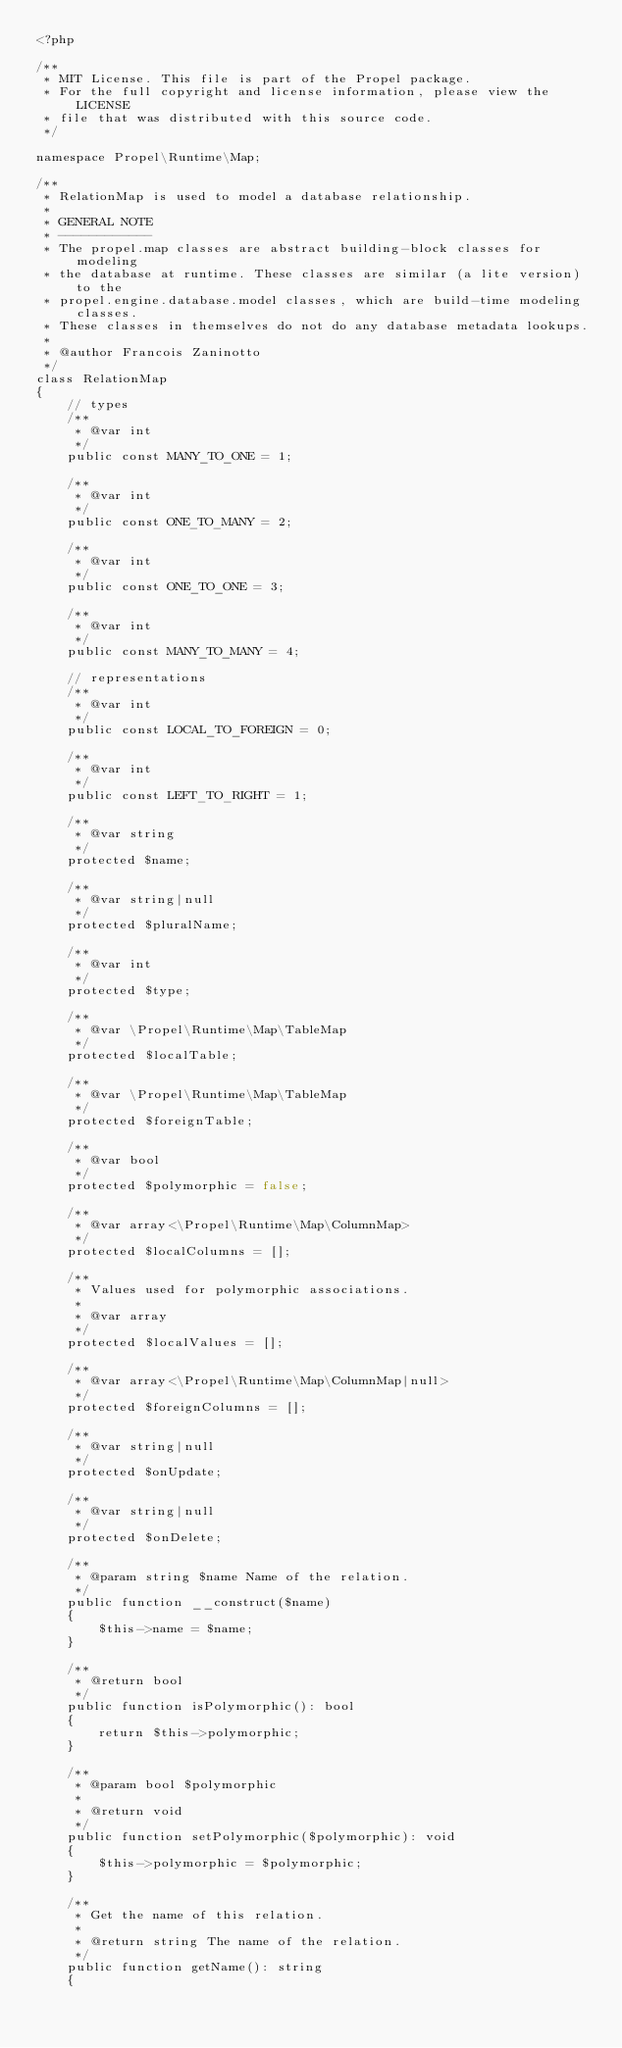Convert code to text. <code><loc_0><loc_0><loc_500><loc_500><_PHP_><?php

/**
 * MIT License. This file is part of the Propel package.
 * For the full copyright and license information, please view the LICENSE
 * file that was distributed with this source code.
 */

namespace Propel\Runtime\Map;

/**
 * RelationMap is used to model a database relationship.
 *
 * GENERAL NOTE
 * ------------
 * The propel.map classes are abstract building-block classes for modeling
 * the database at runtime. These classes are similar (a lite version) to the
 * propel.engine.database.model classes, which are build-time modeling classes.
 * These classes in themselves do not do any database metadata lookups.
 *
 * @author Francois Zaninotto
 */
class RelationMap
{
    // types
    /**
     * @var int
     */
    public const MANY_TO_ONE = 1;

    /**
     * @var int
     */
    public const ONE_TO_MANY = 2;

    /**
     * @var int
     */
    public const ONE_TO_ONE = 3;

    /**
     * @var int
     */
    public const MANY_TO_MANY = 4;

    // representations
    /**
     * @var int
     */
    public const LOCAL_TO_FOREIGN = 0;

    /**
     * @var int
     */
    public const LEFT_TO_RIGHT = 1;

    /**
     * @var string
     */
    protected $name;

    /**
     * @var string|null
     */
    protected $pluralName;

    /**
     * @var int
     */
    protected $type;

    /**
     * @var \Propel\Runtime\Map\TableMap
     */
    protected $localTable;

    /**
     * @var \Propel\Runtime\Map\TableMap
     */
    protected $foreignTable;

    /**
     * @var bool
     */
    protected $polymorphic = false;

    /**
     * @var array<\Propel\Runtime\Map\ColumnMap>
     */
    protected $localColumns = [];

    /**
     * Values used for polymorphic associations.
     *
     * @var array
     */
    protected $localValues = [];

    /**
     * @var array<\Propel\Runtime\Map\ColumnMap|null>
     */
    protected $foreignColumns = [];

    /**
     * @var string|null
     */
    protected $onUpdate;

    /**
     * @var string|null
     */
    protected $onDelete;

    /**
     * @param string $name Name of the relation.
     */
    public function __construct($name)
    {
        $this->name = $name;
    }

    /**
     * @return bool
     */
    public function isPolymorphic(): bool
    {
        return $this->polymorphic;
    }

    /**
     * @param bool $polymorphic
     *
     * @return void
     */
    public function setPolymorphic($polymorphic): void
    {
        $this->polymorphic = $polymorphic;
    }

    /**
     * Get the name of this relation.
     *
     * @return string The name of the relation.
     */
    public function getName(): string
    {</code> 